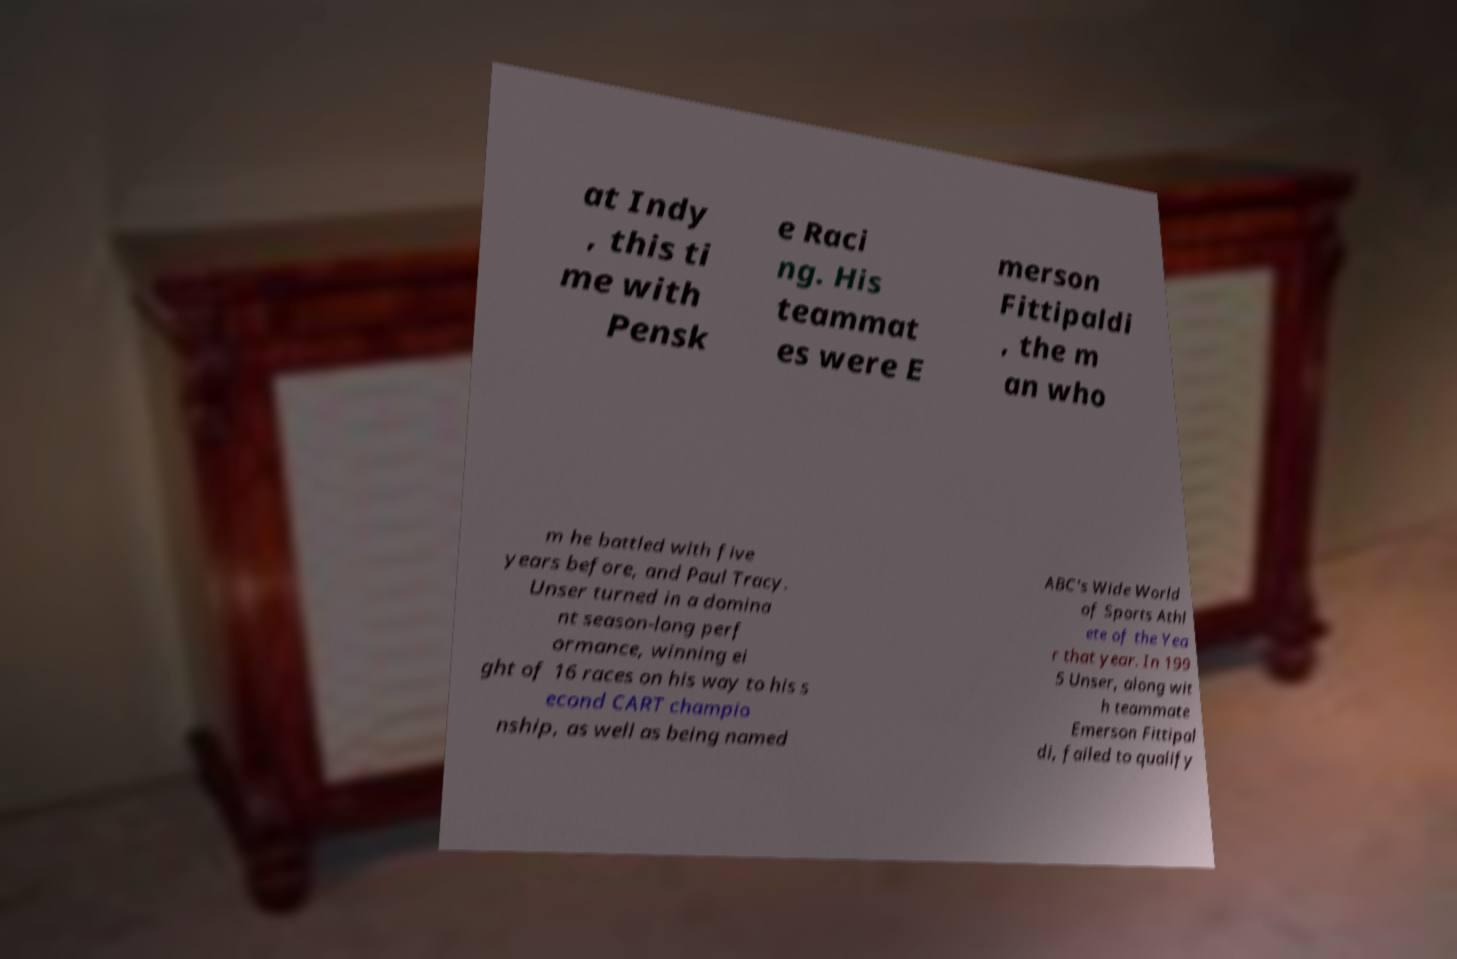Can you accurately transcribe the text from the provided image for me? at Indy , this ti me with Pensk e Raci ng. His teammat es were E merson Fittipaldi , the m an who m he battled with five years before, and Paul Tracy. Unser turned in a domina nt season-long perf ormance, winning ei ght of 16 races on his way to his s econd CART champio nship, as well as being named ABC's Wide World of Sports Athl ete of the Yea r that year. In 199 5 Unser, along wit h teammate Emerson Fittipal di, failed to qualify 